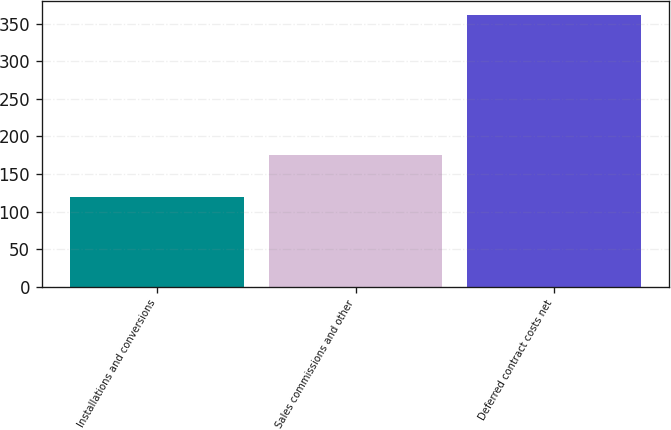<chart> <loc_0><loc_0><loc_500><loc_500><bar_chart><fcel>Installations and conversions<fcel>Sales commissions and other<fcel>Deferred contract costs net<nl><fcel>120<fcel>176<fcel>362<nl></chart> 